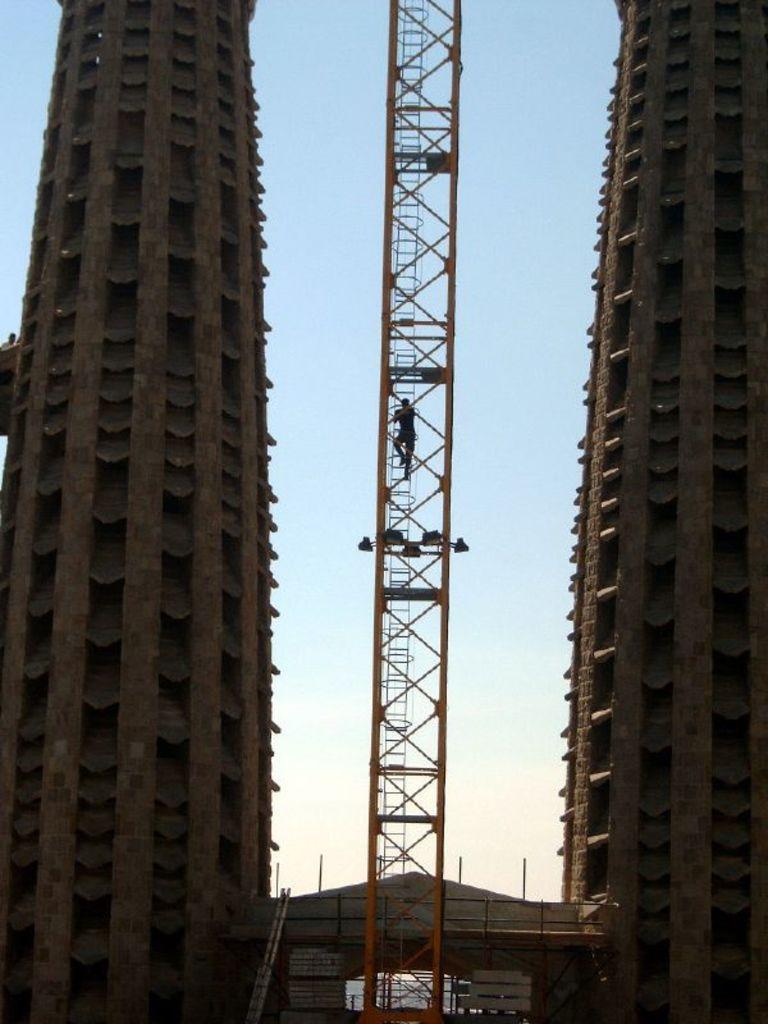Describe this image in one or two sentences. In this image there are two buildings, in the middle there is an iron ladder a person climbing the ladder, in the background there is the sky. 